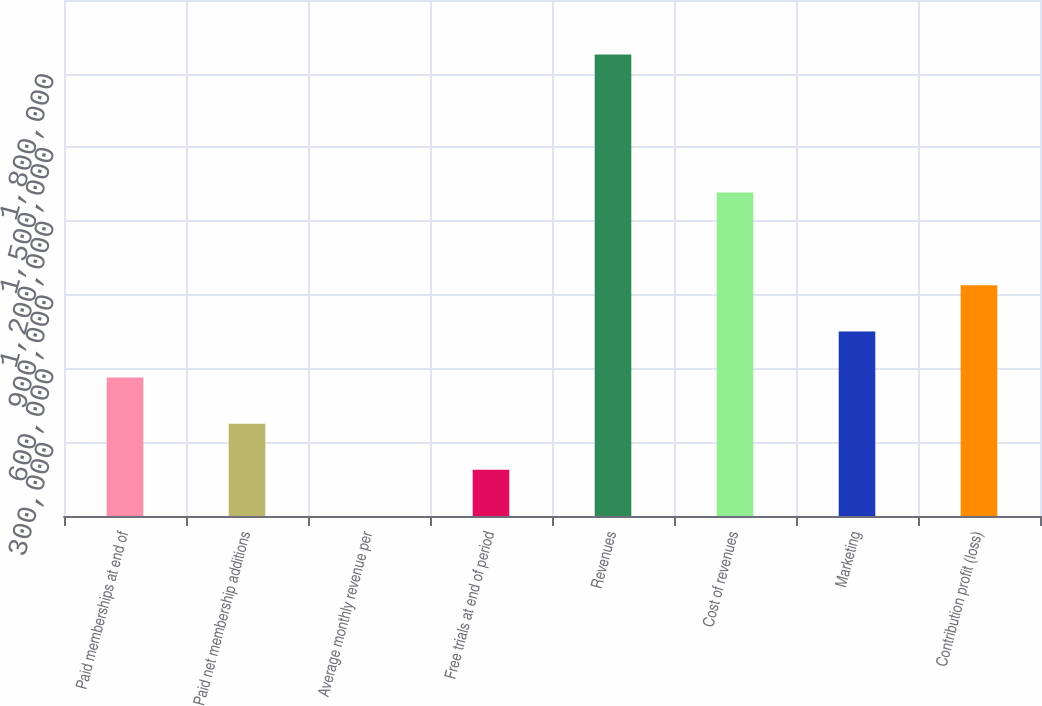<chart> <loc_0><loc_0><loc_500><loc_500><bar_chart><fcel>Paid memberships at end of<fcel>Paid net membership additions<fcel>Average monthly revenue per<fcel>Free trials at end of period<fcel>Revenues<fcel>Cost of revenues<fcel>Marketing<fcel>Contribution profit (loss)<nl><fcel>563429<fcel>375620<fcel>0.85<fcel>187810<fcel>1.8781e+06<fcel>1.31687e+06<fcel>751239<fcel>939048<nl></chart> 